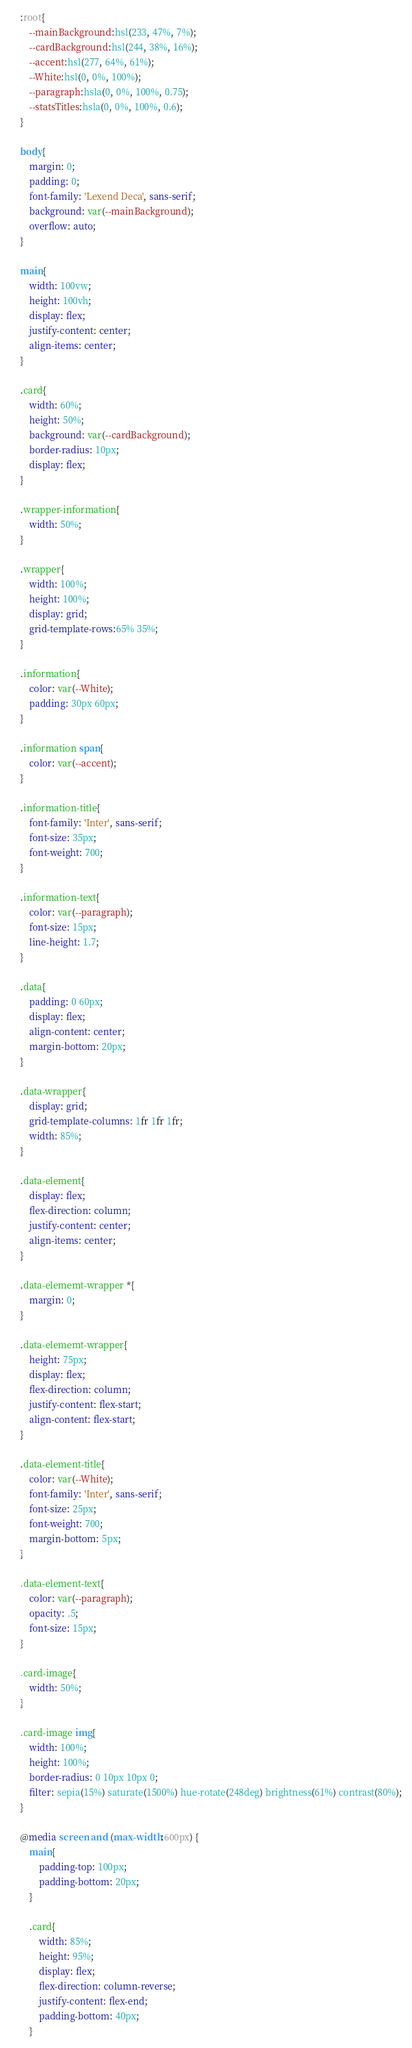Convert code to text. <code><loc_0><loc_0><loc_500><loc_500><_CSS_>:root{
    --mainBackground:hsl(233, 47%, 7%);
    --cardBackground:hsl(244, 38%, 16%);
    --accent:hsl(277, 64%, 61%);
    --White:hsl(0, 0%, 100%);
    --paragraph:hsla(0, 0%, 100%, 0.75);
    --statsTitles:hsla(0, 0%, 100%, 0.6);
}

body{
    margin: 0;
    padding: 0;
    font-family: 'Lexend Deca', sans-serif;
    background: var(--mainBackground);
    overflow: auto;
}

main{
    width: 100vw;
    height: 100vh;
    display: flex;
    justify-content: center;
    align-items: center;
}

.card{
    width: 60%;
    height: 50%;
    background: var(--cardBackground);
    border-radius: 10px;
    display: flex;
}

.wrapper-information{
    width: 50%;
}

.wrapper{
    width: 100%;
    height: 100%;
    display: grid;
    grid-template-rows:65% 35%;
}

.information{
    color: var(--White);
    padding: 30px 60px;
}

.information span{
    color: var(--accent);
}

.information-title{
    font-family: 'Inter', sans-serif;
    font-size: 35px;
    font-weight: 700;
}

.information-text{
    color: var(--paragraph);
    font-size: 15px;
    line-height: 1.7;
}

.data{
    padding: 0 60px;
    display: flex;
    align-content: center;
    margin-bottom: 20px;
}

.data-wrapper{
    display: grid;
    grid-template-columns: 1fr 1fr 1fr;
    width: 85%;
}

.data-element{
    display: flex;
    flex-direction: column;
    justify-content: center;
    align-items: center;
}

.data-elememt-wrapper *{
    margin: 0;
}

.data-elememt-wrapper{
    height: 75px;
    display: flex;
    flex-direction: column;
    justify-content: flex-start;
    align-content: flex-start;
}

.data-element-title{
    color: var(--White);
    font-family: 'Inter', sans-serif;
    font-size: 25px;
    font-weight: 700;
    margin-bottom: 5px;
}

.data-element-text{
    color: var(--paragraph);
    opacity: .5;
    font-size: 15px;
}

.card-image{
    width: 50%;
}

.card-image img{
    width: 100%;
    height: 100%;
    border-radius: 0 10px 10px 0;
    filter: sepia(15%) saturate(1500%) hue-rotate(248deg) brightness(61%) contrast(80%);
}

@media screen and (max-width:600px) {
    main{
        padding-top: 100px;
        padding-bottom: 20px;
    }

    .card{
        width: 85%;
        height: 95%;
        display: flex;
        flex-direction: column-reverse;
        justify-content: flex-end;
        padding-bottom: 40px;
    }
</code> 